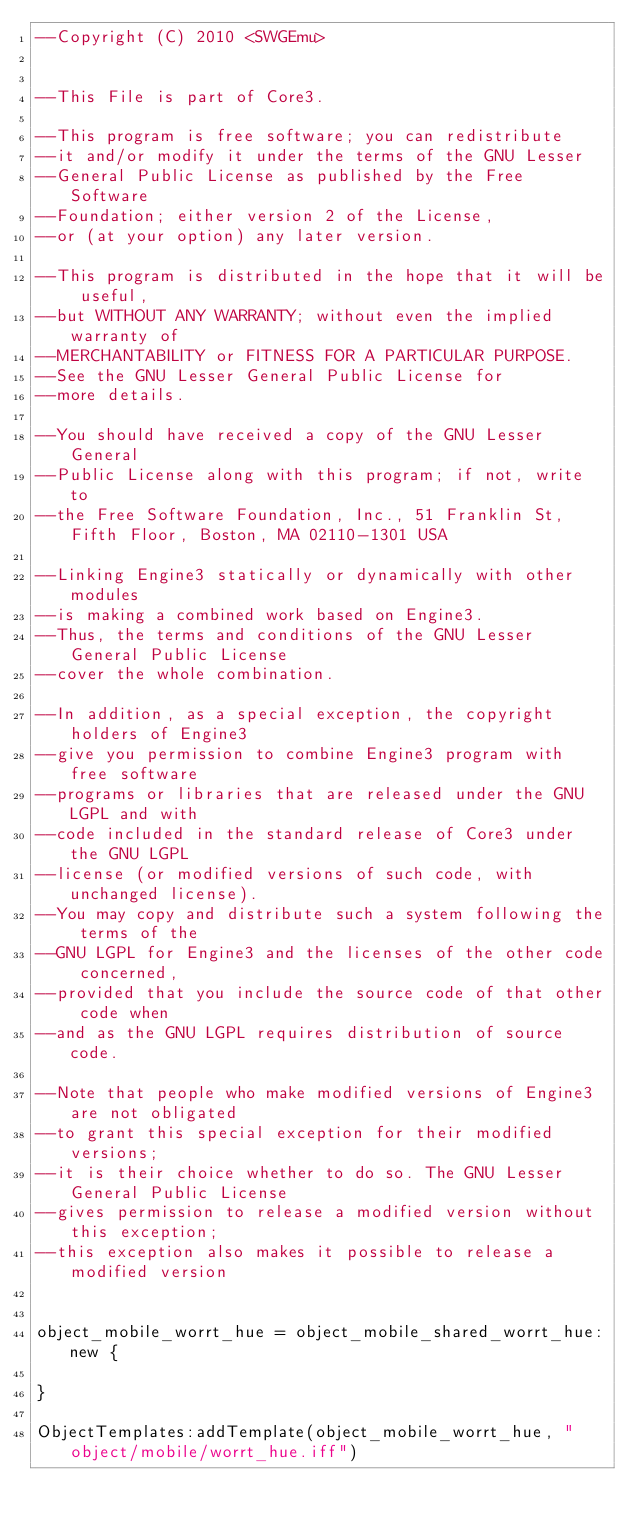<code> <loc_0><loc_0><loc_500><loc_500><_Lua_>--Copyright (C) 2010 <SWGEmu>


--This File is part of Core3.

--This program is free software; you can redistribute 
--it and/or modify it under the terms of the GNU Lesser 
--General Public License as published by the Free Software
--Foundation; either version 2 of the License, 
--or (at your option) any later version.

--This program is distributed in the hope that it will be useful, 
--but WITHOUT ANY WARRANTY; without even the implied warranty of 
--MERCHANTABILITY or FITNESS FOR A PARTICULAR PURPOSE. 
--See the GNU Lesser General Public License for
--more details.

--You should have received a copy of the GNU Lesser General 
--Public License along with this program; if not, write to
--the Free Software Foundation, Inc., 51 Franklin St, Fifth Floor, Boston, MA 02110-1301 USA

--Linking Engine3 statically or dynamically with other modules 
--is making a combined work based on Engine3. 
--Thus, the terms and conditions of the GNU Lesser General Public License 
--cover the whole combination.

--In addition, as a special exception, the copyright holders of Engine3 
--give you permission to combine Engine3 program with free software 
--programs or libraries that are released under the GNU LGPL and with 
--code included in the standard release of Core3 under the GNU LGPL 
--license (or modified versions of such code, with unchanged license). 
--You may copy and distribute such a system following the terms of the 
--GNU LGPL for Engine3 and the licenses of the other code concerned, 
--provided that you include the source code of that other code when 
--and as the GNU LGPL requires distribution of source code.

--Note that people who make modified versions of Engine3 are not obligated 
--to grant this special exception for their modified versions; 
--it is their choice whether to do so. The GNU Lesser General Public License 
--gives permission to release a modified version without this exception; 
--this exception also makes it possible to release a modified version 


object_mobile_worrt_hue = object_mobile_shared_worrt_hue:new {

}

ObjectTemplates:addTemplate(object_mobile_worrt_hue, "object/mobile/worrt_hue.iff")
</code> 